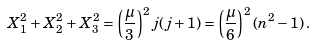Convert formula to latex. <formula><loc_0><loc_0><loc_500><loc_500>X _ { 1 } ^ { 2 } + X _ { 2 } ^ { 2 } + X _ { 3 } ^ { 2 } = \left ( { \frac { \mu } { 3 } } \right ) ^ { 2 } j ( j + 1 ) = \left ( { \frac { \mu } { 6 } } \right ) ^ { 2 } ( n ^ { 2 } - 1 ) \, .</formula> 